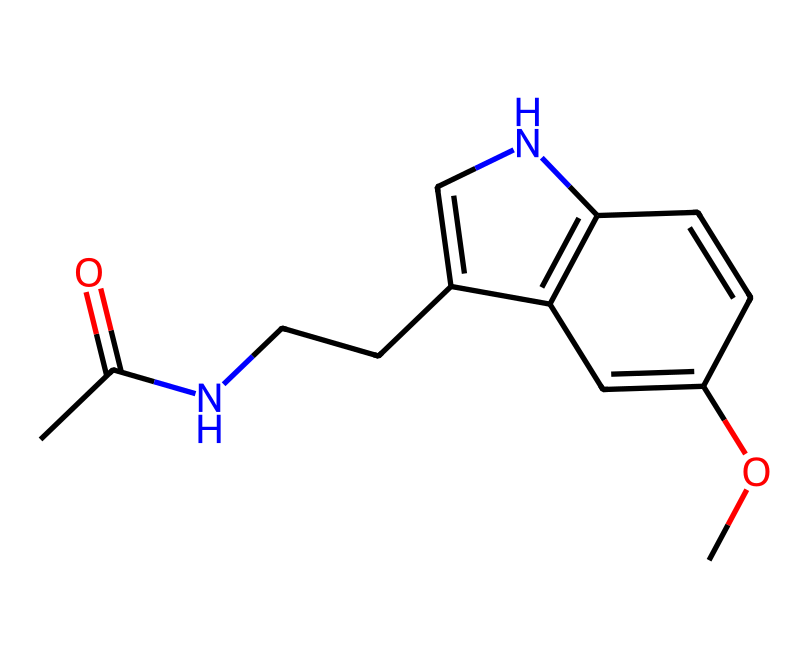What is the name of this compound? The SMILES representation corresponds to melatonin, a hormone that regulates sleep-wake cycles. The chemical structure consists of an indole ring and an acetyl group that are characteristic of melatonin.
Answer: melatonin How many carbon atoms are present? By analyzing the SMILES representation, we can count the number of 'C' characters and observe the structure visually. There are 13 carbon atoms in total in the compound.
Answer: 13 What is the total number of nitrogen atoms? The SMILES representation includes 'N' characters that indicate the presence of nitrogen atoms. In this compound, there are two nitrogen atoms present.
Answer: 2 What functional groups are represented? The presence of the 'CC(=O)' indicates an acetyl group, while the 'N' atoms show the presence of amine functionality. Coupled with the indole structure, these represent the main functional groups in melatonin.
Answer: acetyl and amine What does this compound primarily help with? Considering the known effect of melatonin in human biology and its common usage, this compound is primarily used as a sleep aid, particularly for adjusting sleep cycles for shift workers.
Answer: sleep aid How does the configuration of the nitrogen contribute to this compound's function? The nitrogen in the indole ring and associated amine influence the neurotransmitter activity and signaling pathways in the brain, which is essential for melatonin’s role in sleep regulation.
Answer: neurotransmitter activity 